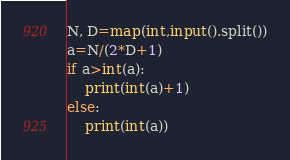<code> <loc_0><loc_0><loc_500><loc_500><_Python_>N, D=map(int,input().split())
a=N/(2*D+1)
if a>int(a):
    print(int(a)+1)
else:
    print(int(a))</code> 